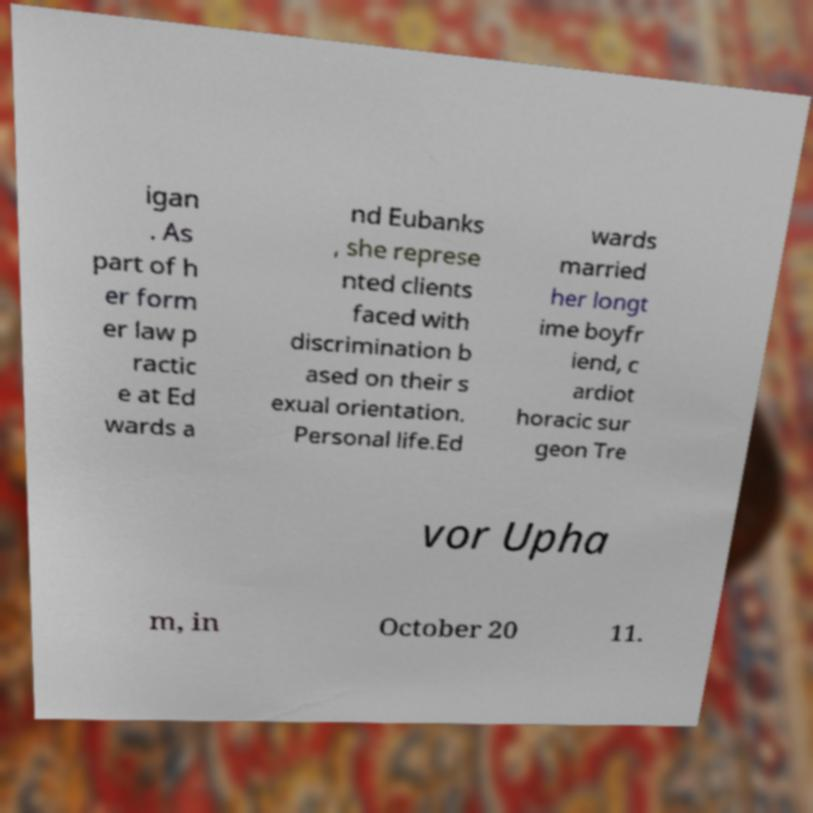There's text embedded in this image that I need extracted. Can you transcribe it verbatim? igan . As part of h er form er law p ractic e at Ed wards a nd Eubanks , she represe nted clients faced with discrimination b ased on their s exual orientation. Personal life.Ed wards married her longt ime boyfr iend, c ardiot horacic sur geon Tre vor Upha m, in October 20 11. 